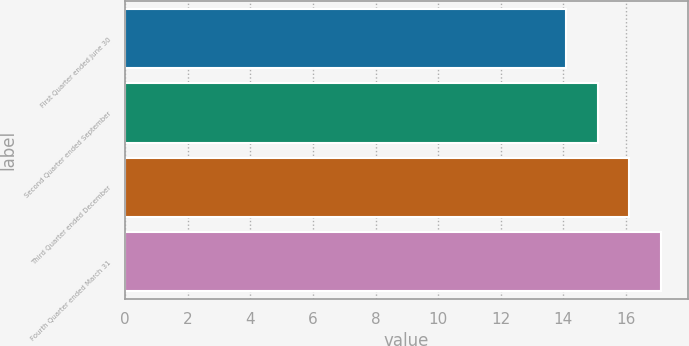Convert chart to OTSL. <chart><loc_0><loc_0><loc_500><loc_500><bar_chart><fcel>First Quarter ended June 30<fcel>Second Quarter ended September<fcel>Third Quarter ended December<fcel>Fourth Quarter ended March 31<nl><fcel>14.08<fcel>15.09<fcel>16.1<fcel>17.11<nl></chart> 